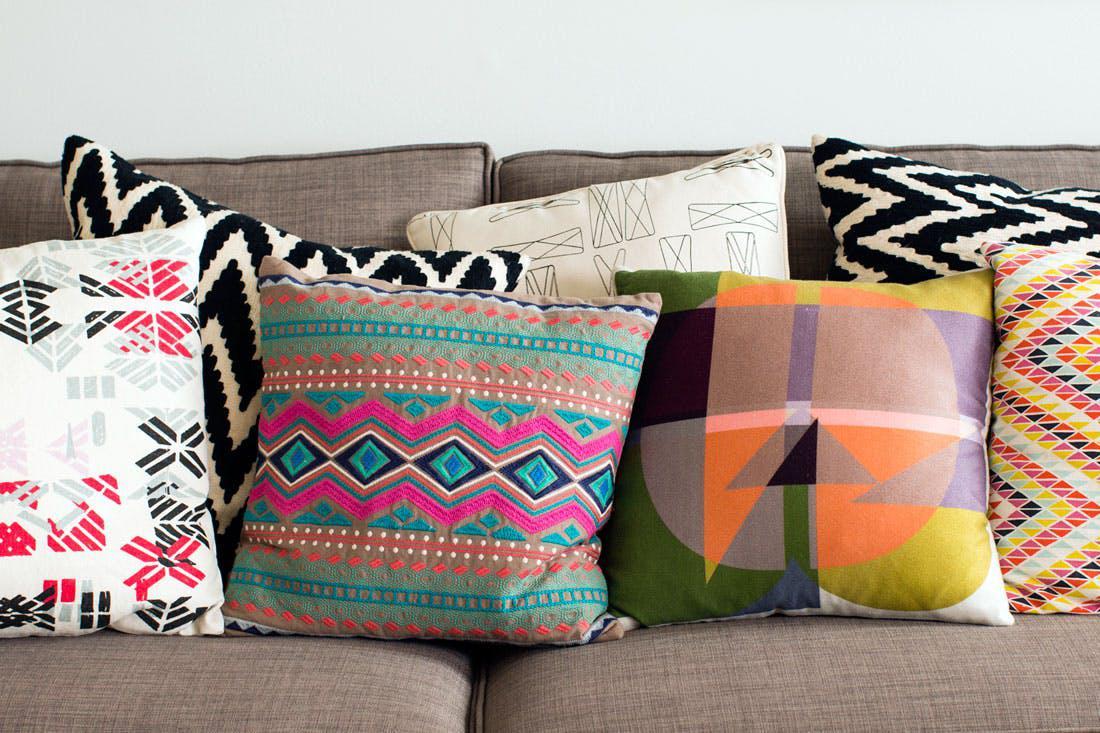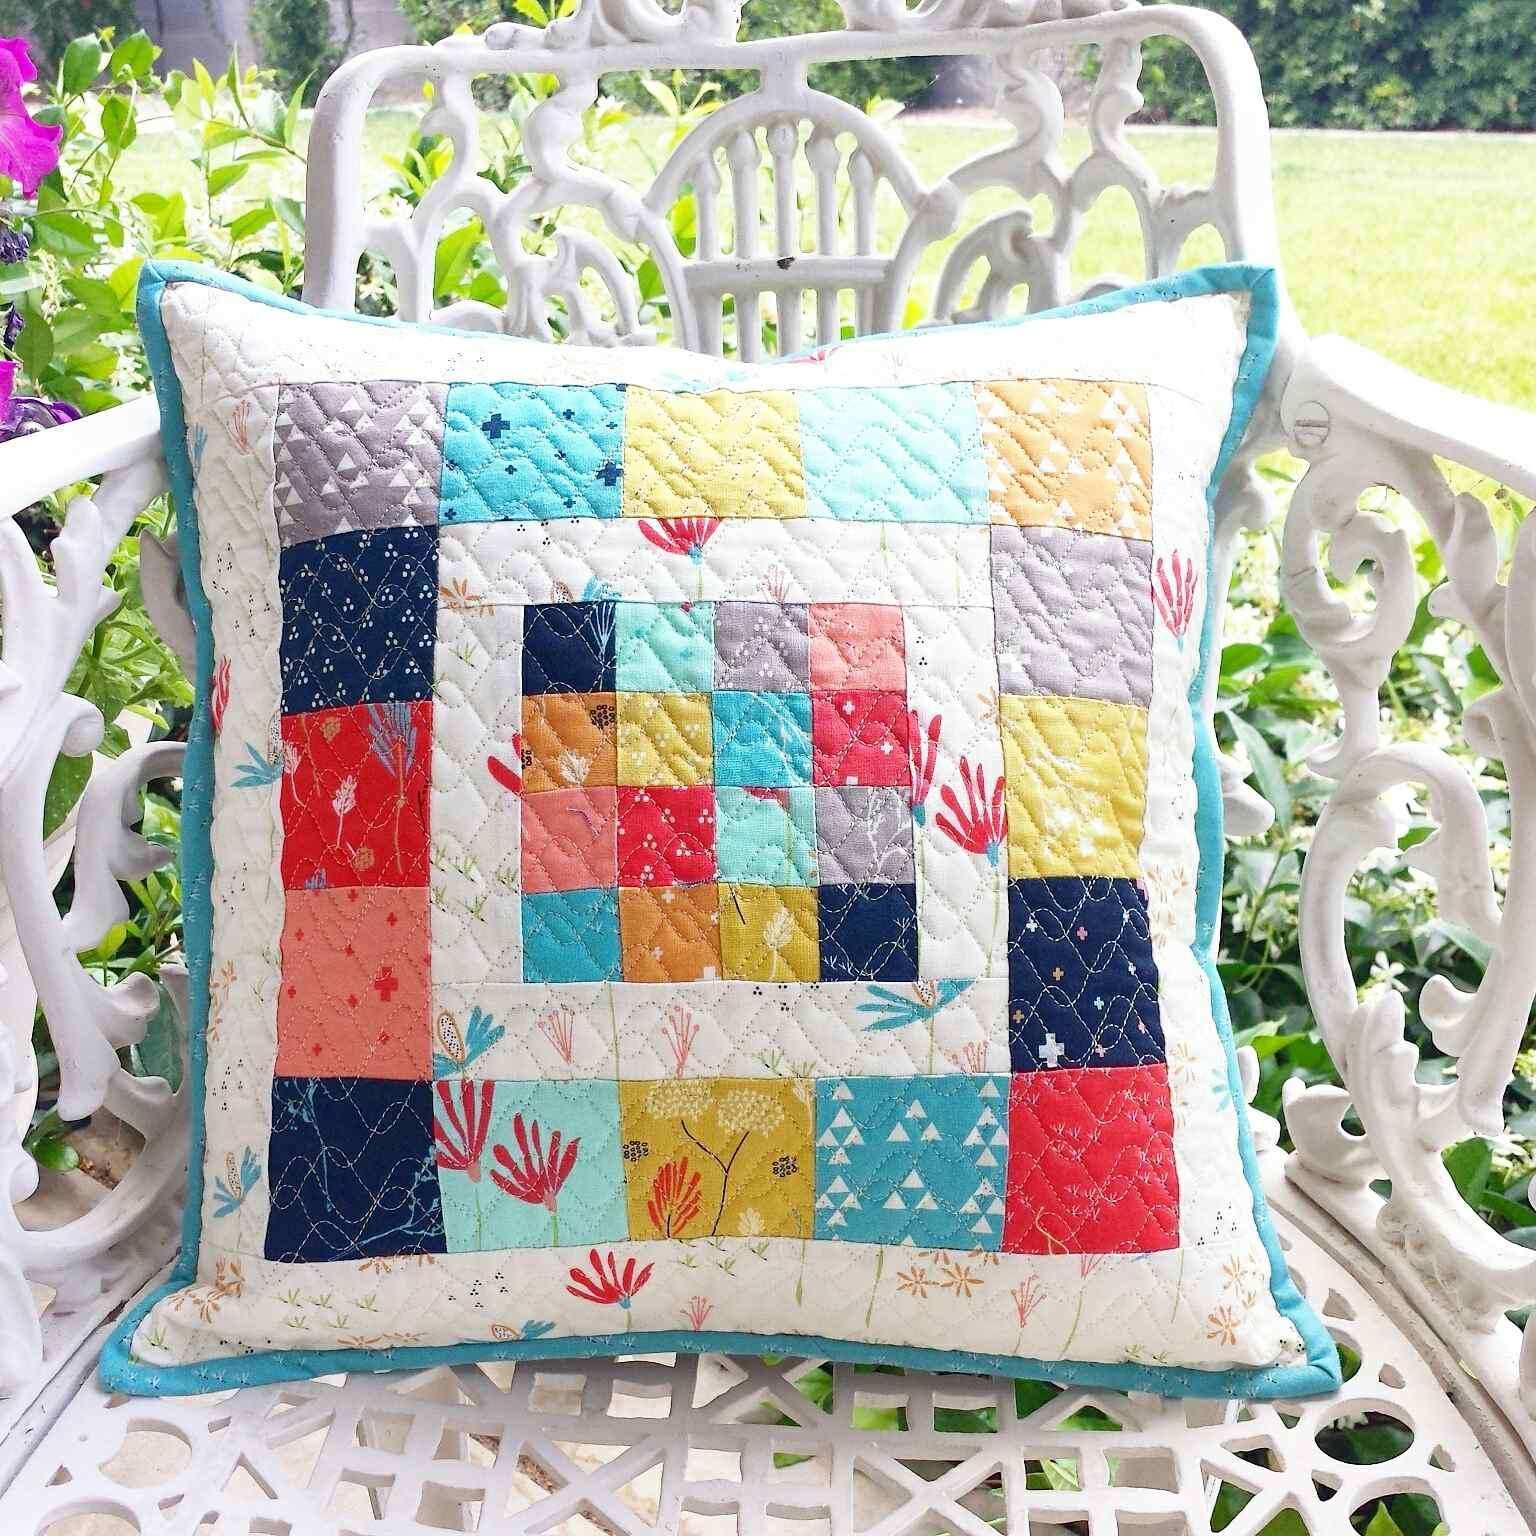The first image is the image on the left, the second image is the image on the right. Considering the images on both sides, is "Some of the pillows are round in shape." valid? Answer yes or no. No. The first image is the image on the left, the second image is the image on the right. Analyze the images presented: Is the assertion "The pillow display in one image includes a round wheel shape with a button center." valid? Answer yes or no. No. 